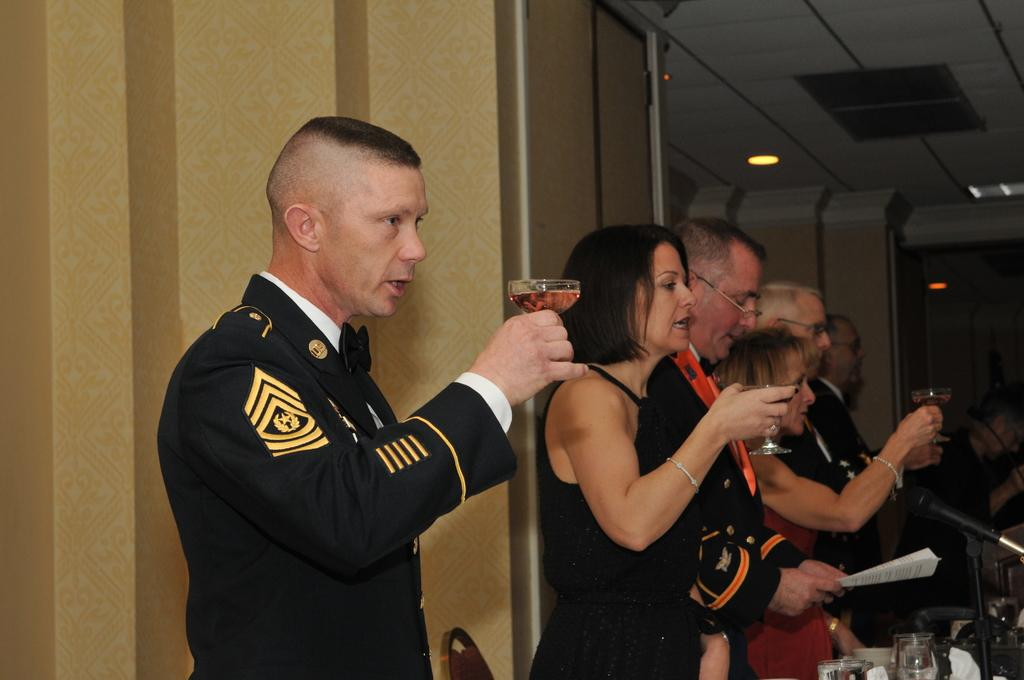What are the people in the image doing? The people in the image are standing and holding drink glasses. What object can be seen in the image that is typically used for amplifying sound? There is a microphone in the image. What is the background of the image made of? There is a wall in the image, which is likely the background. What part of the room is visible in the image? The ceiling is visible in the image, and there are lights on the ceiling. How many sheep are visible in the image? There are no sheep present in the image. What type of approval is being given by the people in the image? There is no indication of approval or disapproval in the image; the people are simply holding drink glasses. 